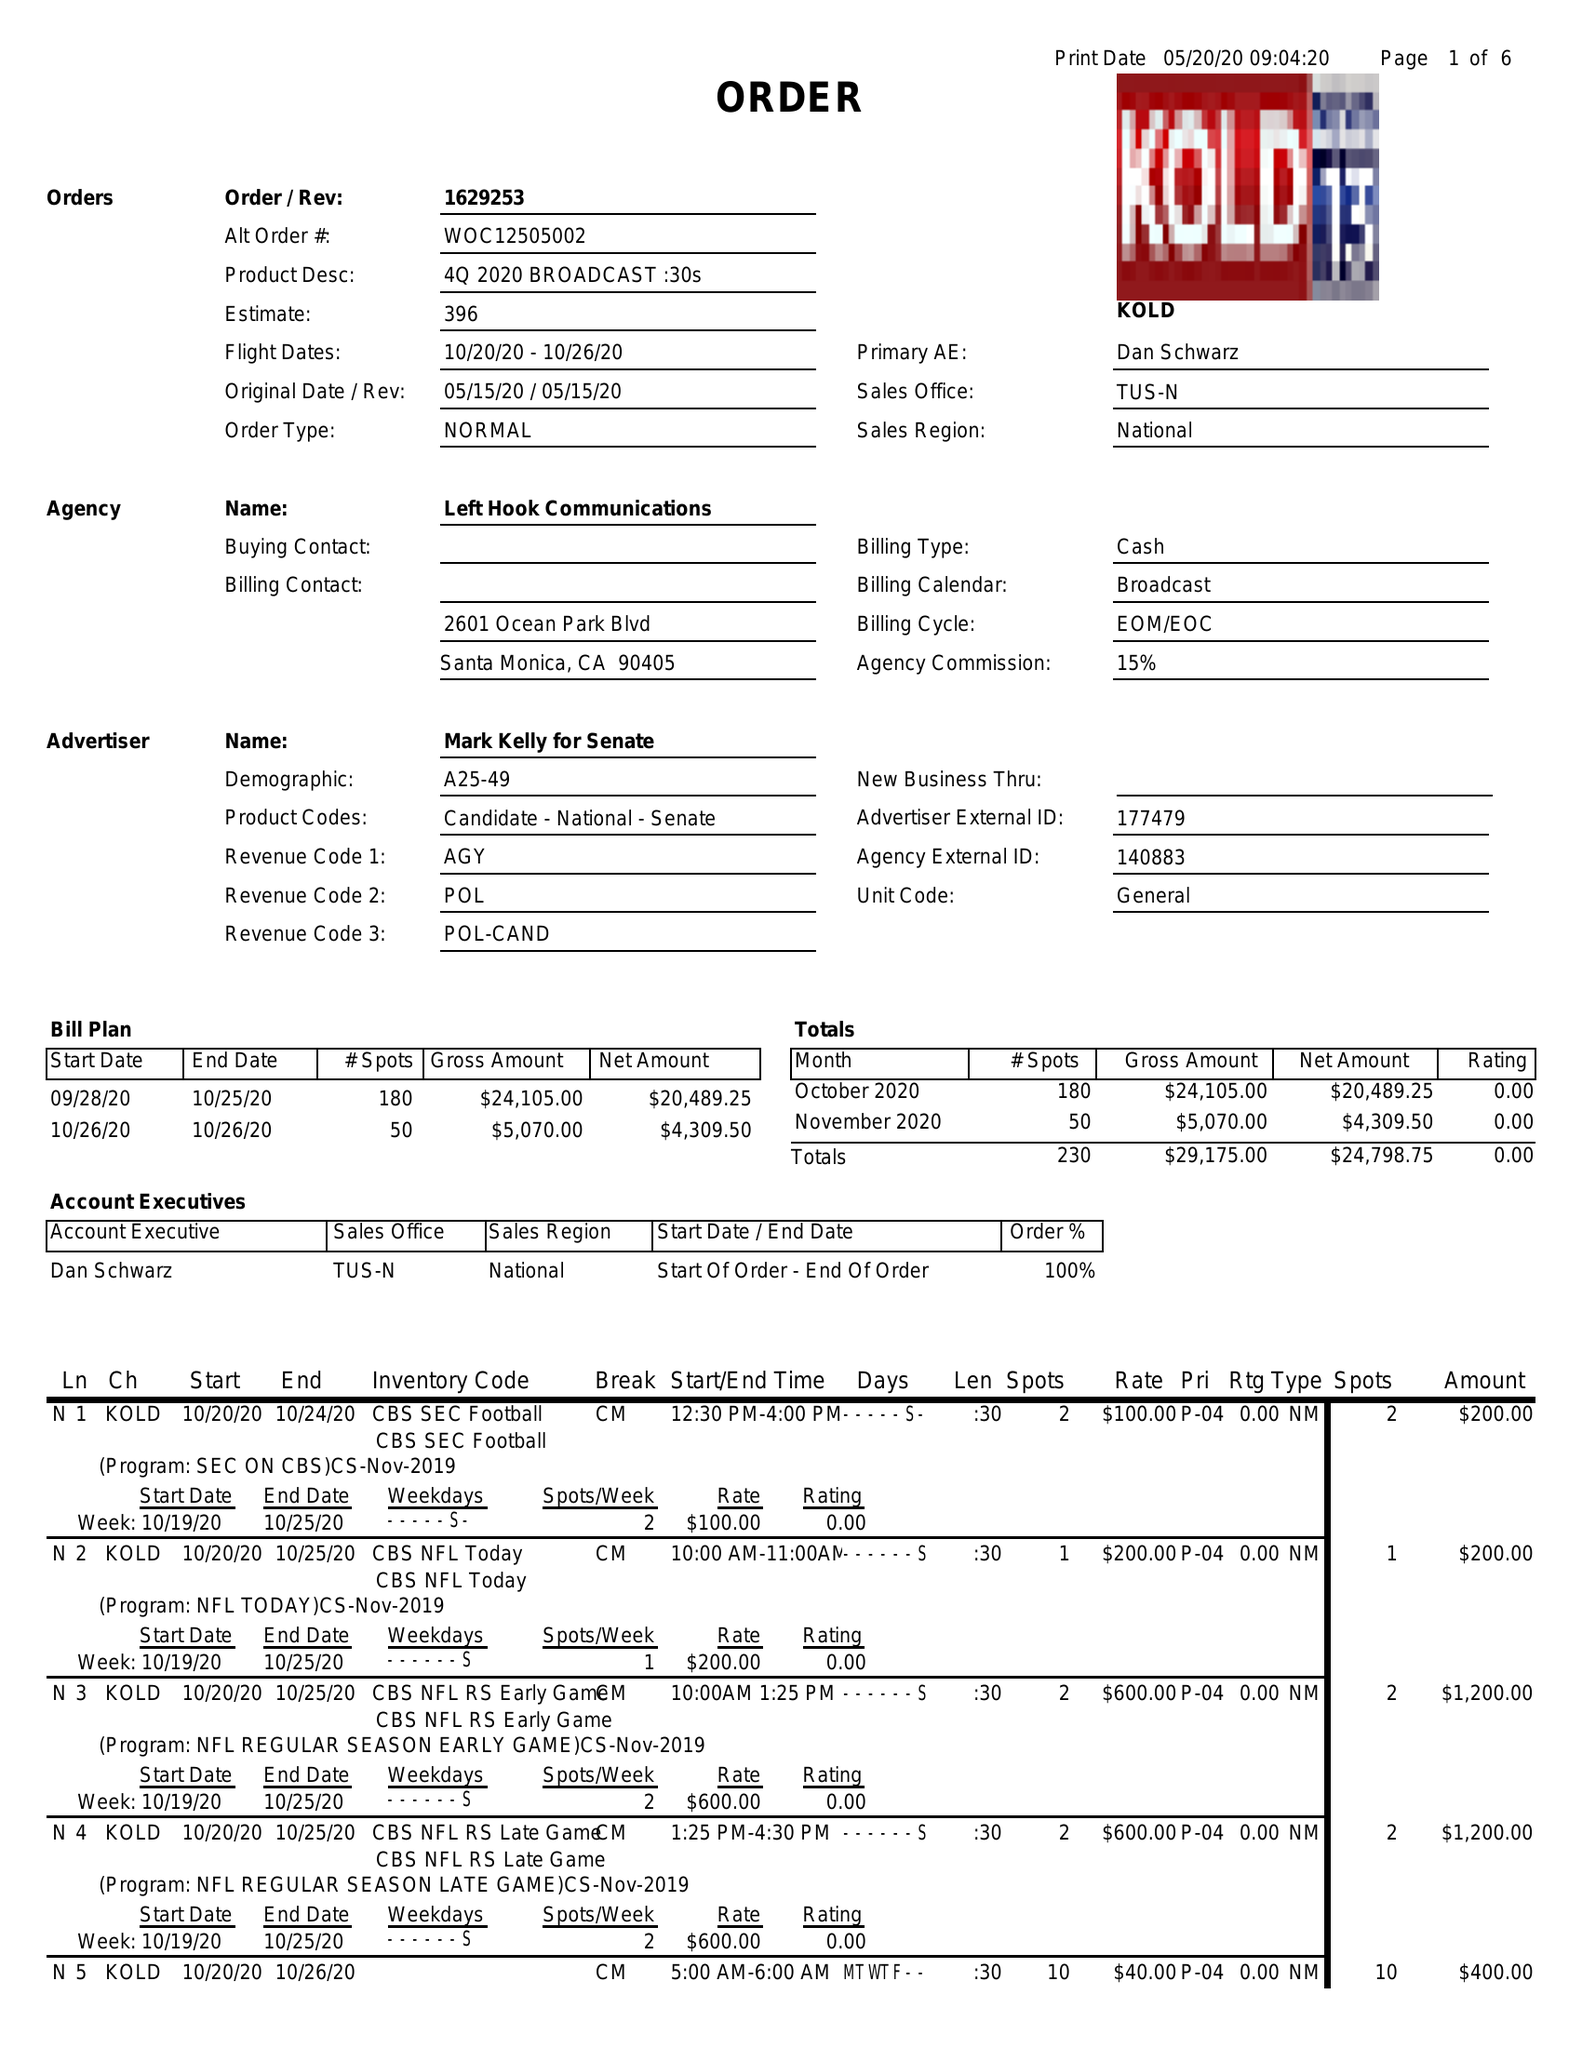What is the value for the gross_amount?
Answer the question using a single word or phrase. 29175.00 